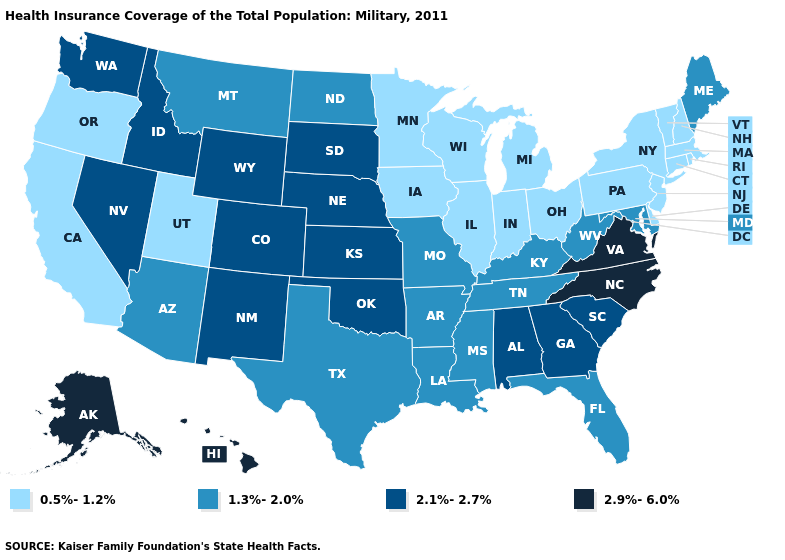What is the highest value in the MidWest ?
Keep it brief. 2.1%-2.7%. What is the lowest value in states that border North Carolina?
Quick response, please. 1.3%-2.0%. Is the legend a continuous bar?
Keep it brief. No. Does Louisiana have the lowest value in the USA?
Short answer required. No. Is the legend a continuous bar?
Quick response, please. No. Name the states that have a value in the range 0.5%-1.2%?
Concise answer only. California, Connecticut, Delaware, Illinois, Indiana, Iowa, Massachusetts, Michigan, Minnesota, New Hampshire, New Jersey, New York, Ohio, Oregon, Pennsylvania, Rhode Island, Utah, Vermont, Wisconsin. What is the highest value in the USA?
Give a very brief answer. 2.9%-6.0%. Which states have the lowest value in the USA?
Answer briefly. California, Connecticut, Delaware, Illinois, Indiana, Iowa, Massachusetts, Michigan, Minnesota, New Hampshire, New Jersey, New York, Ohio, Oregon, Pennsylvania, Rhode Island, Utah, Vermont, Wisconsin. Is the legend a continuous bar?
Short answer required. No. Does Wisconsin have a lower value than Rhode Island?
Quick response, please. No. What is the value of Rhode Island?
Quick response, please. 0.5%-1.2%. Name the states that have a value in the range 2.1%-2.7%?
Quick response, please. Alabama, Colorado, Georgia, Idaho, Kansas, Nebraska, Nevada, New Mexico, Oklahoma, South Carolina, South Dakota, Washington, Wyoming. Does Maine have the lowest value in the Northeast?
Concise answer only. No. Does the map have missing data?
Quick response, please. No. What is the value of Virginia?
Quick response, please. 2.9%-6.0%. 